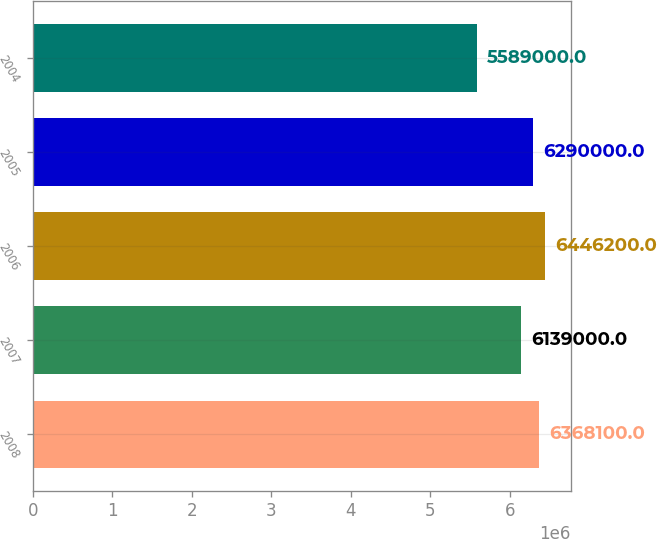<chart> <loc_0><loc_0><loc_500><loc_500><bar_chart><fcel>2008<fcel>2007<fcel>2006<fcel>2005<fcel>2004<nl><fcel>6.3681e+06<fcel>6.139e+06<fcel>6.4462e+06<fcel>6.29e+06<fcel>5.589e+06<nl></chart> 